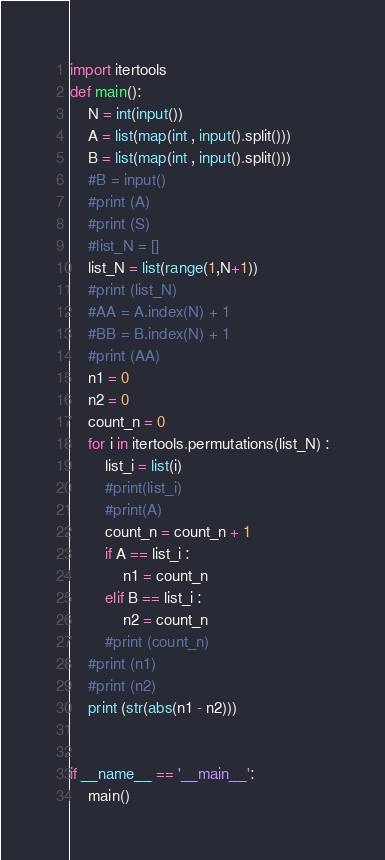Convert code to text. <code><loc_0><loc_0><loc_500><loc_500><_Python_>import itertools
def main():
    N = int(input())
    A = list(map(int , input().split()))
    B = list(map(int , input().split()))
    #B = input()
    #print (A)
    #print (S)
    #list_N = []
    list_N = list(range(1,N+1))
    #print (list_N)
    #AA = A.index(N) + 1
    #BB = B.index(N) + 1
    #print (AA)
    n1 = 0
    n2 = 0
    count_n = 0
    for i in itertools.permutations(list_N) :
        list_i = list(i)
        #print(list_i)
        #print(A)
        count_n = count_n + 1
        if A == list_i :
            n1 = count_n
        elif B == list_i :
            n2 = count_n
        #print (count_n)
    #print (n1)
    #print (n2)
    print (str(abs(n1 - n2)))


if __name__ == '__main__':
    main()</code> 